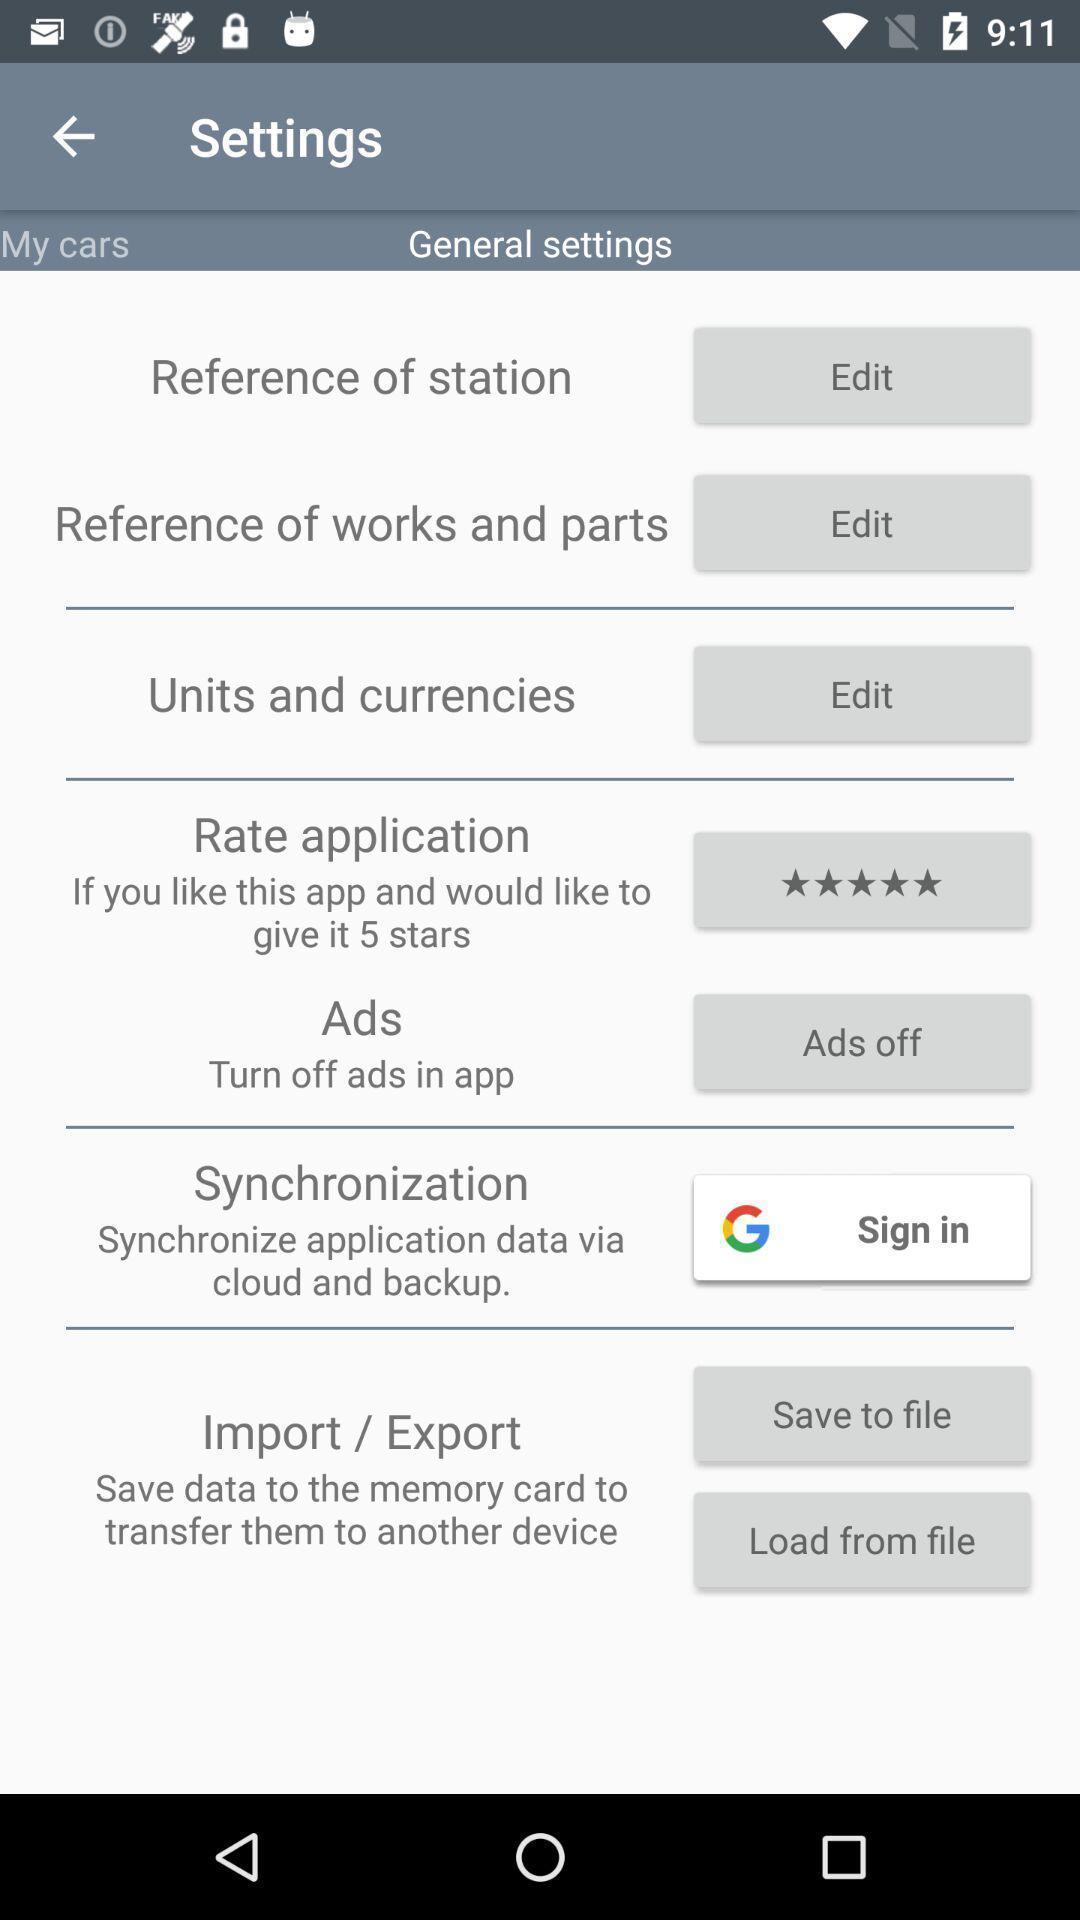Describe the visual elements of this screenshot. Screen displaying the settings page. 